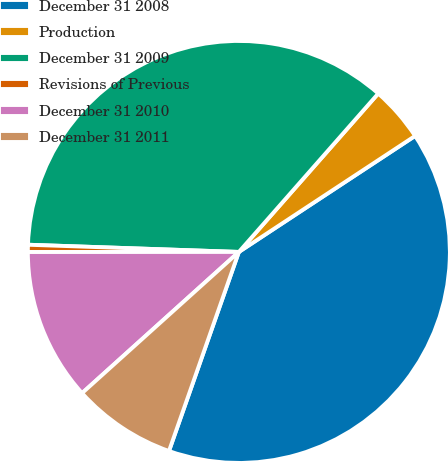<chart> <loc_0><loc_0><loc_500><loc_500><pie_chart><fcel>December 31 2008<fcel>Production<fcel>December 31 2009<fcel>Revisions of Previous<fcel>December 31 2010<fcel>December 31 2011<nl><fcel>39.64%<fcel>4.25%<fcel>35.94%<fcel>0.55%<fcel>11.66%<fcel>7.96%<nl></chart> 